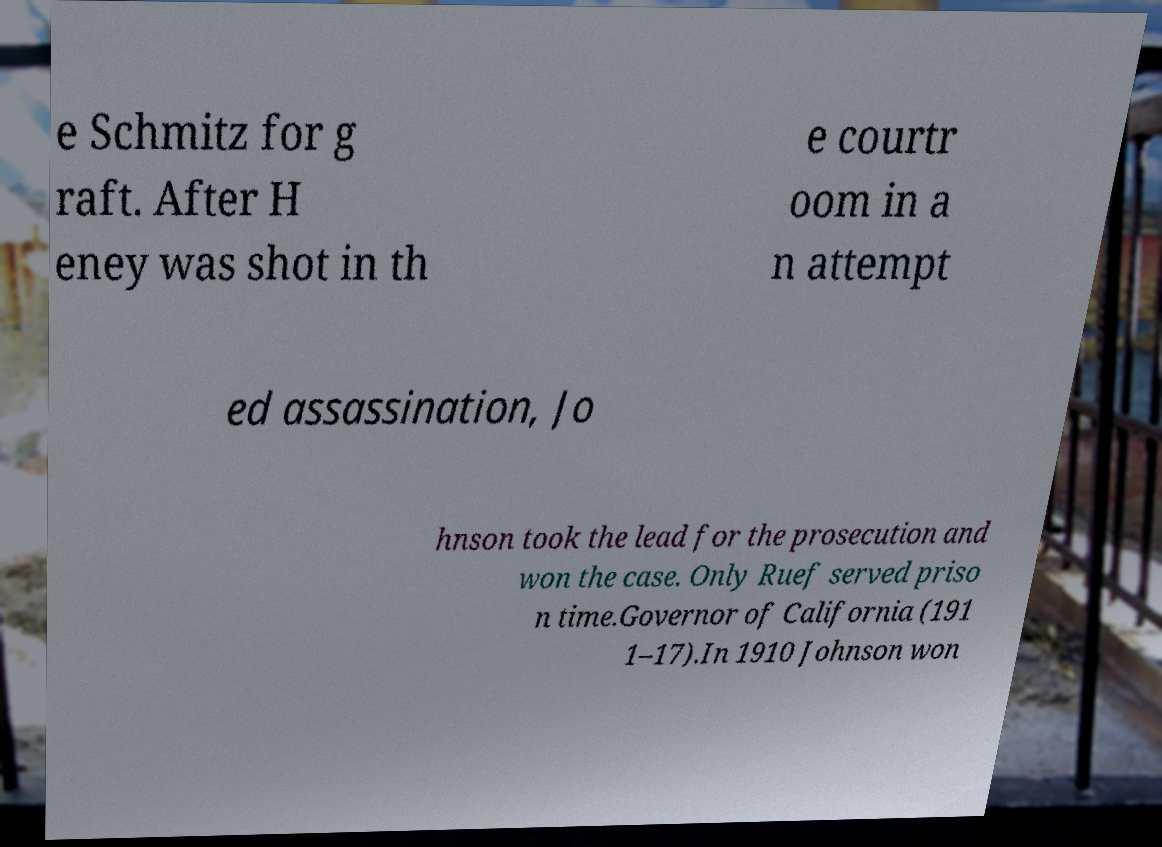I need the written content from this picture converted into text. Can you do that? e Schmitz for g raft. After H eney was shot in th e courtr oom in a n attempt ed assassination, Jo hnson took the lead for the prosecution and won the case. Only Ruef served priso n time.Governor of California (191 1–17).In 1910 Johnson won 